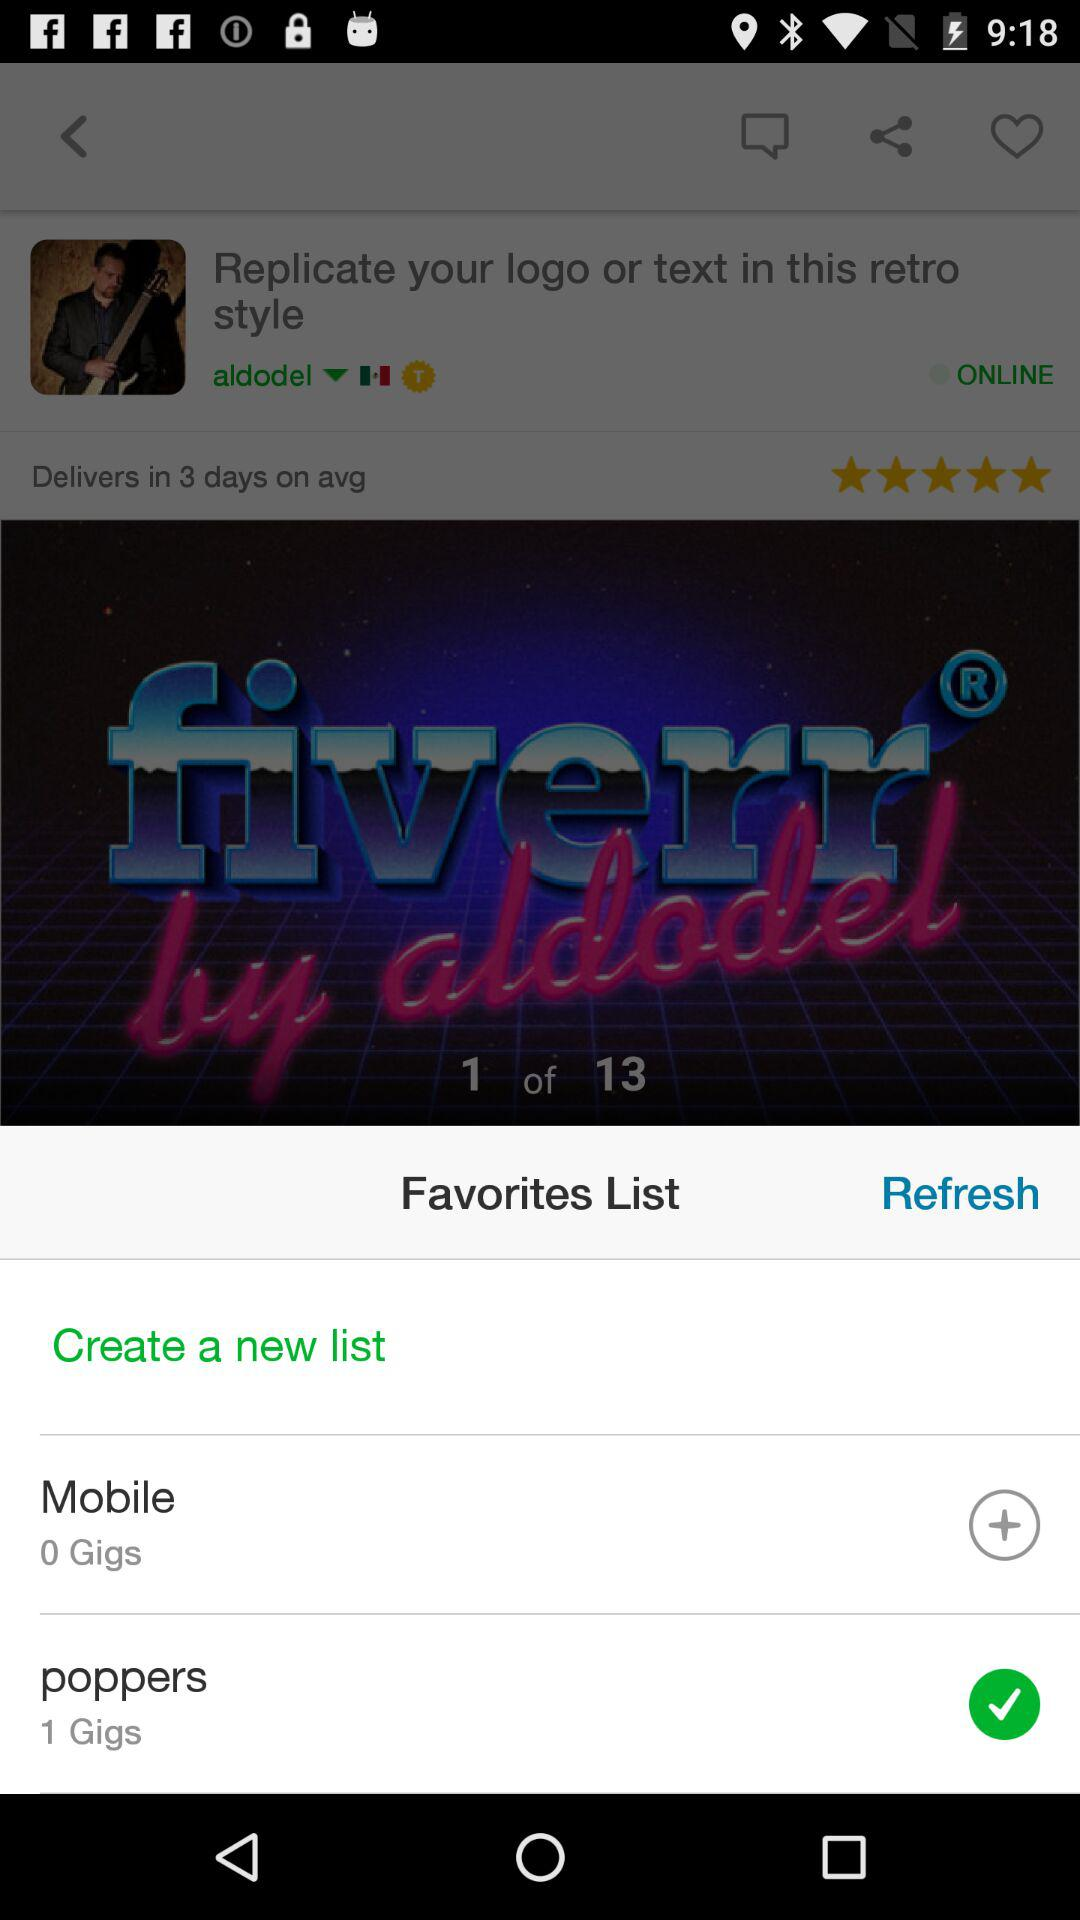What is the average delivery time? The average delivery time is 3 days. 